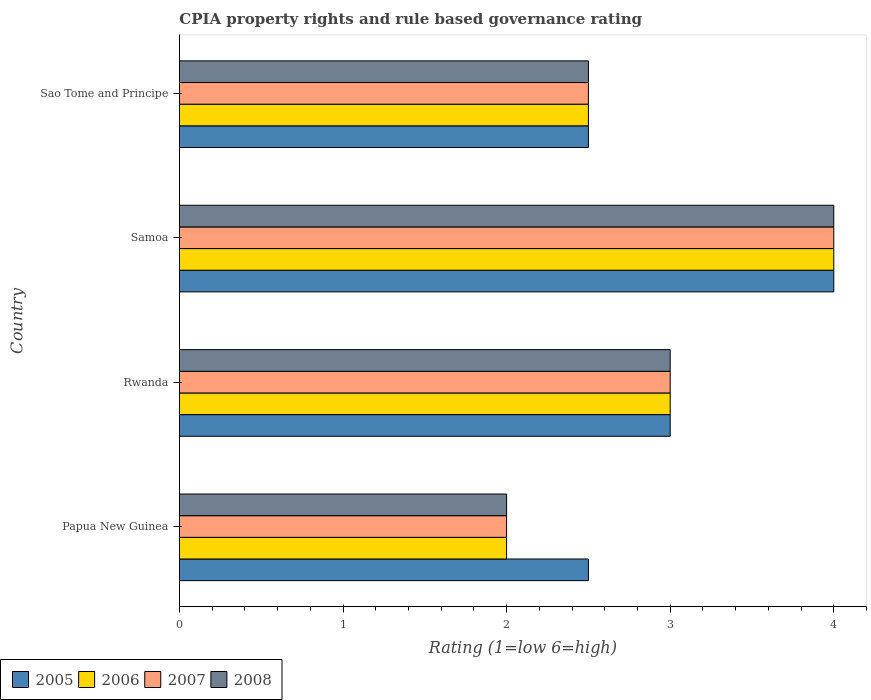How many different coloured bars are there?
Offer a very short reply. 4. How many groups of bars are there?
Your response must be concise. 4. Are the number of bars per tick equal to the number of legend labels?
Your response must be concise. Yes. How many bars are there on the 4th tick from the bottom?
Provide a short and direct response. 4. What is the label of the 4th group of bars from the top?
Make the answer very short. Papua New Guinea. In how many cases, is the number of bars for a given country not equal to the number of legend labels?
Your answer should be very brief. 0. In which country was the CPIA rating in 2006 maximum?
Provide a succinct answer. Samoa. In which country was the CPIA rating in 2008 minimum?
Your response must be concise. Papua New Guinea. What is the total CPIA rating in 2006 in the graph?
Ensure brevity in your answer.  11.5. What is the difference between the CPIA rating in 2008 in Papua New Guinea and that in Sao Tome and Principe?
Offer a terse response. -0.5. What is the difference between the CPIA rating in 2005 in Rwanda and the CPIA rating in 2006 in Samoa?
Provide a short and direct response. -1. What is the average CPIA rating in 2008 per country?
Ensure brevity in your answer.  2.88. What is the difference between the CPIA rating in 2006 and CPIA rating in 2008 in Rwanda?
Give a very brief answer. 0. What is the ratio of the CPIA rating in 2005 in Papua New Guinea to that in Rwanda?
Provide a succinct answer. 0.83. Is the CPIA rating in 2008 in Rwanda less than that in Sao Tome and Principe?
Provide a short and direct response. No. Is the difference between the CPIA rating in 2006 in Papua New Guinea and Samoa greater than the difference between the CPIA rating in 2008 in Papua New Guinea and Samoa?
Offer a very short reply. No. What is the difference between the highest and the lowest CPIA rating in 2006?
Provide a short and direct response. 2. In how many countries, is the CPIA rating in 2006 greater than the average CPIA rating in 2006 taken over all countries?
Give a very brief answer. 2. Is the sum of the CPIA rating in 2007 in Papua New Guinea and Rwanda greater than the maximum CPIA rating in 2008 across all countries?
Your response must be concise. Yes. What does the 4th bar from the bottom in Sao Tome and Principe represents?
Provide a succinct answer. 2008. Is it the case that in every country, the sum of the CPIA rating in 2007 and CPIA rating in 2006 is greater than the CPIA rating in 2005?
Give a very brief answer. Yes. How many countries are there in the graph?
Keep it short and to the point. 4. What is the difference between two consecutive major ticks on the X-axis?
Your answer should be very brief. 1. Does the graph contain any zero values?
Your answer should be very brief. No. How many legend labels are there?
Offer a terse response. 4. How are the legend labels stacked?
Make the answer very short. Horizontal. What is the title of the graph?
Provide a succinct answer. CPIA property rights and rule based governance rating. Does "2003" appear as one of the legend labels in the graph?
Offer a very short reply. No. What is the label or title of the X-axis?
Provide a short and direct response. Rating (1=low 6=high). What is the Rating (1=low 6=high) of 2006 in Papua New Guinea?
Make the answer very short. 2. What is the Rating (1=low 6=high) in 2007 in Papua New Guinea?
Keep it short and to the point. 2. What is the Rating (1=low 6=high) of 2006 in Rwanda?
Ensure brevity in your answer.  3. What is the Rating (1=low 6=high) of 2008 in Rwanda?
Ensure brevity in your answer.  3. What is the Rating (1=low 6=high) of 2005 in Samoa?
Your response must be concise. 4. What is the Rating (1=low 6=high) in 2007 in Samoa?
Keep it short and to the point. 4. What is the Rating (1=low 6=high) in 2008 in Samoa?
Your response must be concise. 4. What is the Rating (1=low 6=high) of 2005 in Sao Tome and Principe?
Make the answer very short. 2.5. What is the Rating (1=low 6=high) of 2006 in Sao Tome and Principe?
Offer a very short reply. 2.5. What is the Rating (1=low 6=high) in 2007 in Sao Tome and Principe?
Your answer should be very brief. 2.5. What is the Rating (1=low 6=high) of 2008 in Sao Tome and Principe?
Provide a succinct answer. 2.5. Across all countries, what is the maximum Rating (1=low 6=high) of 2007?
Ensure brevity in your answer.  4. Across all countries, what is the maximum Rating (1=low 6=high) of 2008?
Offer a terse response. 4. Across all countries, what is the minimum Rating (1=low 6=high) in 2005?
Provide a short and direct response. 2.5. Across all countries, what is the minimum Rating (1=low 6=high) in 2007?
Your response must be concise. 2. What is the total Rating (1=low 6=high) in 2007 in the graph?
Your response must be concise. 11.5. What is the difference between the Rating (1=low 6=high) of 2005 in Papua New Guinea and that in Rwanda?
Give a very brief answer. -0.5. What is the difference between the Rating (1=low 6=high) of 2008 in Papua New Guinea and that in Rwanda?
Offer a very short reply. -1. What is the difference between the Rating (1=low 6=high) in 2005 in Papua New Guinea and that in Samoa?
Offer a terse response. -1.5. What is the difference between the Rating (1=low 6=high) in 2006 in Papua New Guinea and that in Samoa?
Ensure brevity in your answer.  -2. What is the difference between the Rating (1=low 6=high) of 2007 in Papua New Guinea and that in Samoa?
Keep it short and to the point. -2. What is the difference between the Rating (1=low 6=high) in 2008 in Papua New Guinea and that in Samoa?
Your response must be concise. -2. What is the difference between the Rating (1=low 6=high) of 2006 in Papua New Guinea and that in Sao Tome and Principe?
Your answer should be very brief. -0.5. What is the difference between the Rating (1=low 6=high) of 2008 in Papua New Guinea and that in Sao Tome and Principe?
Your answer should be compact. -0.5. What is the difference between the Rating (1=low 6=high) in 2006 in Rwanda and that in Samoa?
Your answer should be compact. -1. What is the difference between the Rating (1=low 6=high) of 2005 in Rwanda and that in Sao Tome and Principe?
Make the answer very short. 0.5. What is the difference between the Rating (1=low 6=high) of 2006 in Samoa and that in Sao Tome and Principe?
Ensure brevity in your answer.  1.5. What is the difference between the Rating (1=low 6=high) in 2005 in Papua New Guinea and the Rating (1=low 6=high) in 2008 in Rwanda?
Keep it short and to the point. -0.5. What is the difference between the Rating (1=low 6=high) in 2006 in Papua New Guinea and the Rating (1=low 6=high) in 2007 in Rwanda?
Provide a succinct answer. -1. What is the difference between the Rating (1=low 6=high) in 2005 in Papua New Guinea and the Rating (1=low 6=high) in 2006 in Samoa?
Make the answer very short. -1.5. What is the difference between the Rating (1=low 6=high) in 2005 in Papua New Guinea and the Rating (1=low 6=high) in 2007 in Samoa?
Give a very brief answer. -1.5. What is the difference between the Rating (1=low 6=high) in 2005 in Papua New Guinea and the Rating (1=low 6=high) in 2008 in Samoa?
Give a very brief answer. -1.5. What is the difference between the Rating (1=low 6=high) of 2006 in Papua New Guinea and the Rating (1=low 6=high) of 2007 in Samoa?
Your answer should be compact. -2. What is the difference between the Rating (1=low 6=high) of 2007 in Papua New Guinea and the Rating (1=low 6=high) of 2008 in Samoa?
Offer a very short reply. -2. What is the difference between the Rating (1=low 6=high) of 2005 in Papua New Guinea and the Rating (1=low 6=high) of 2006 in Sao Tome and Principe?
Give a very brief answer. 0. What is the difference between the Rating (1=low 6=high) of 2005 in Papua New Guinea and the Rating (1=low 6=high) of 2007 in Sao Tome and Principe?
Your answer should be compact. 0. What is the difference between the Rating (1=low 6=high) of 2005 in Papua New Guinea and the Rating (1=low 6=high) of 2008 in Sao Tome and Principe?
Your answer should be compact. 0. What is the difference between the Rating (1=low 6=high) in 2006 in Papua New Guinea and the Rating (1=low 6=high) in 2007 in Sao Tome and Principe?
Your answer should be compact. -0.5. What is the difference between the Rating (1=low 6=high) in 2005 in Rwanda and the Rating (1=low 6=high) in 2006 in Samoa?
Ensure brevity in your answer.  -1. What is the difference between the Rating (1=low 6=high) of 2005 in Rwanda and the Rating (1=low 6=high) of 2007 in Samoa?
Keep it short and to the point. -1. What is the difference between the Rating (1=low 6=high) in 2005 in Rwanda and the Rating (1=low 6=high) in 2008 in Samoa?
Keep it short and to the point. -1. What is the difference between the Rating (1=low 6=high) in 2005 in Rwanda and the Rating (1=low 6=high) in 2008 in Sao Tome and Principe?
Your answer should be compact. 0.5. What is the difference between the Rating (1=low 6=high) in 2005 in Samoa and the Rating (1=low 6=high) in 2008 in Sao Tome and Principe?
Your response must be concise. 1.5. What is the difference between the Rating (1=low 6=high) in 2006 in Samoa and the Rating (1=low 6=high) in 2007 in Sao Tome and Principe?
Your answer should be compact. 1.5. What is the difference between the Rating (1=low 6=high) in 2006 in Samoa and the Rating (1=low 6=high) in 2008 in Sao Tome and Principe?
Your response must be concise. 1.5. What is the average Rating (1=low 6=high) of 2006 per country?
Give a very brief answer. 2.88. What is the average Rating (1=low 6=high) in 2007 per country?
Provide a short and direct response. 2.88. What is the average Rating (1=low 6=high) in 2008 per country?
Your answer should be very brief. 2.88. What is the difference between the Rating (1=low 6=high) of 2005 and Rating (1=low 6=high) of 2006 in Papua New Guinea?
Offer a very short reply. 0.5. What is the difference between the Rating (1=low 6=high) in 2005 and Rating (1=low 6=high) in 2007 in Papua New Guinea?
Your response must be concise. 0.5. What is the difference between the Rating (1=low 6=high) in 2006 and Rating (1=low 6=high) in 2007 in Papua New Guinea?
Offer a very short reply. 0. What is the difference between the Rating (1=low 6=high) in 2006 and Rating (1=low 6=high) in 2008 in Papua New Guinea?
Make the answer very short. 0. What is the difference between the Rating (1=low 6=high) in 2005 and Rating (1=low 6=high) in 2006 in Rwanda?
Keep it short and to the point. 0. What is the difference between the Rating (1=low 6=high) in 2005 and Rating (1=low 6=high) in 2008 in Rwanda?
Keep it short and to the point. 0. What is the difference between the Rating (1=low 6=high) in 2006 and Rating (1=low 6=high) in 2007 in Rwanda?
Your answer should be very brief. 0. What is the difference between the Rating (1=low 6=high) of 2006 and Rating (1=low 6=high) of 2008 in Rwanda?
Your answer should be compact. 0. What is the difference between the Rating (1=low 6=high) in 2007 and Rating (1=low 6=high) in 2008 in Rwanda?
Give a very brief answer. 0. What is the difference between the Rating (1=low 6=high) of 2005 and Rating (1=low 6=high) of 2008 in Samoa?
Ensure brevity in your answer.  0. What is the difference between the Rating (1=low 6=high) of 2006 and Rating (1=low 6=high) of 2007 in Samoa?
Keep it short and to the point. 0. What is the difference between the Rating (1=low 6=high) of 2006 and Rating (1=low 6=high) of 2008 in Samoa?
Offer a terse response. 0. What is the difference between the Rating (1=low 6=high) of 2005 and Rating (1=low 6=high) of 2006 in Sao Tome and Principe?
Provide a short and direct response. 0. What is the difference between the Rating (1=low 6=high) in 2005 and Rating (1=low 6=high) in 2007 in Sao Tome and Principe?
Make the answer very short. 0. What is the difference between the Rating (1=low 6=high) in 2006 and Rating (1=low 6=high) in 2007 in Sao Tome and Principe?
Provide a succinct answer. 0. What is the difference between the Rating (1=low 6=high) of 2006 and Rating (1=low 6=high) of 2008 in Sao Tome and Principe?
Make the answer very short. 0. What is the ratio of the Rating (1=low 6=high) of 2005 in Papua New Guinea to that in Rwanda?
Provide a short and direct response. 0.83. What is the ratio of the Rating (1=low 6=high) of 2005 in Papua New Guinea to that in Samoa?
Offer a terse response. 0.62. What is the ratio of the Rating (1=low 6=high) of 2007 in Papua New Guinea to that in Samoa?
Provide a succinct answer. 0.5. What is the ratio of the Rating (1=low 6=high) of 2005 in Papua New Guinea to that in Sao Tome and Principe?
Provide a short and direct response. 1. What is the ratio of the Rating (1=low 6=high) of 2006 in Papua New Guinea to that in Sao Tome and Principe?
Ensure brevity in your answer.  0.8. What is the ratio of the Rating (1=low 6=high) in 2008 in Papua New Guinea to that in Sao Tome and Principe?
Your answer should be compact. 0.8. What is the ratio of the Rating (1=low 6=high) of 2005 in Rwanda to that in Sao Tome and Principe?
Keep it short and to the point. 1.2. What is the ratio of the Rating (1=low 6=high) of 2007 in Rwanda to that in Sao Tome and Principe?
Your answer should be compact. 1.2. What is the ratio of the Rating (1=low 6=high) of 2008 in Samoa to that in Sao Tome and Principe?
Provide a succinct answer. 1.6. What is the difference between the highest and the second highest Rating (1=low 6=high) in 2005?
Give a very brief answer. 1. What is the difference between the highest and the second highest Rating (1=low 6=high) of 2006?
Your answer should be very brief. 1. What is the difference between the highest and the lowest Rating (1=low 6=high) of 2005?
Give a very brief answer. 1.5. What is the difference between the highest and the lowest Rating (1=low 6=high) in 2006?
Offer a very short reply. 2. What is the difference between the highest and the lowest Rating (1=low 6=high) of 2007?
Your answer should be compact. 2. What is the difference between the highest and the lowest Rating (1=low 6=high) of 2008?
Offer a terse response. 2. 